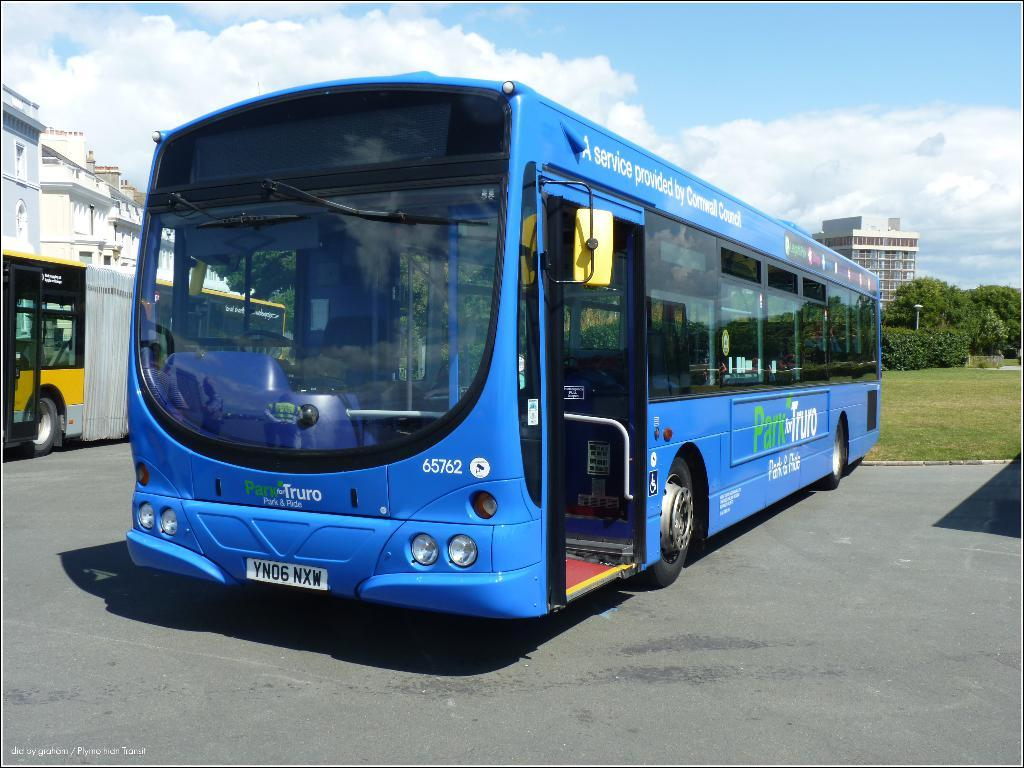What vehicles are parked in the image? There are two buses parked in the image. What can be seen in the background of the image? There are buildings, trees, a pole, and the sky visible in the background of the image. Where are the ants crawling on the floor in the image? There are no ants present in the image, and therefore no crawling can be observed on the floor. 